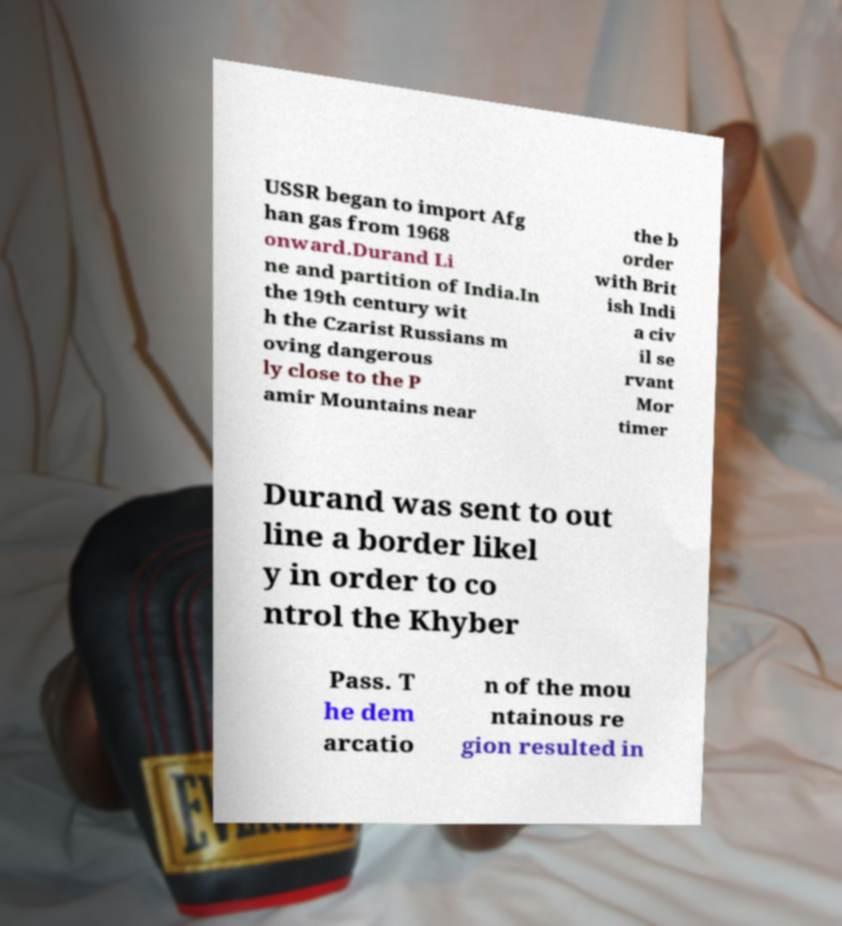Can you read and provide the text displayed in the image?This photo seems to have some interesting text. Can you extract and type it out for me? USSR began to import Afg han gas from 1968 onward.Durand Li ne and partition of India.In the 19th century wit h the Czarist Russians m oving dangerous ly close to the P amir Mountains near the b order with Brit ish Indi a civ il se rvant Mor timer Durand was sent to out line a border likel y in order to co ntrol the Khyber Pass. T he dem arcatio n of the mou ntainous re gion resulted in 